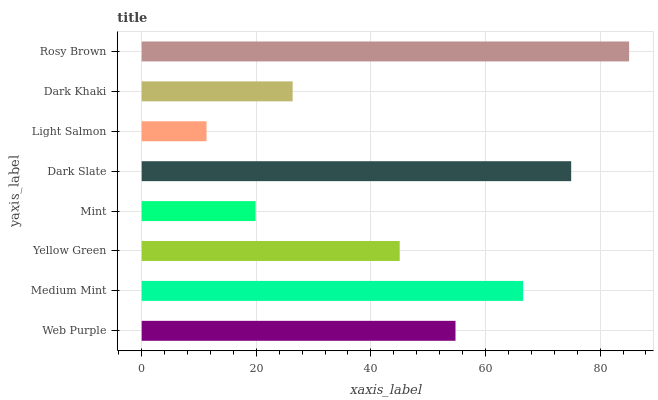Is Light Salmon the minimum?
Answer yes or no. Yes. Is Rosy Brown the maximum?
Answer yes or no. Yes. Is Medium Mint the minimum?
Answer yes or no. No. Is Medium Mint the maximum?
Answer yes or no. No. Is Medium Mint greater than Web Purple?
Answer yes or no. Yes. Is Web Purple less than Medium Mint?
Answer yes or no. Yes. Is Web Purple greater than Medium Mint?
Answer yes or no. No. Is Medium Mint less than Web Purple?
Answer yes or no. No. Is Web Purple the high median?
Answer yes or no. Yes. Is Yellow Green the low median?
Answer yes or no. Yes. Is Medium Mint the high median?
Answer yes or no. No. Is Rosy Brown the low median?
Answer yes or no. No. 